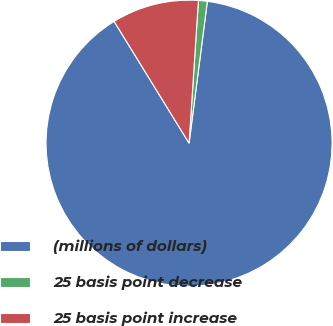Convert chart to OTSL. <chart><loc_0><loc_0><loc_500><loc_500><pie_chart><fcel>(millions of dollars)<fcel>25 basis point decrease<fcel>25 basis point increase<nl><fcel>89.17%<fcel>1.0%<fcel>9.82%<nl></chart> 